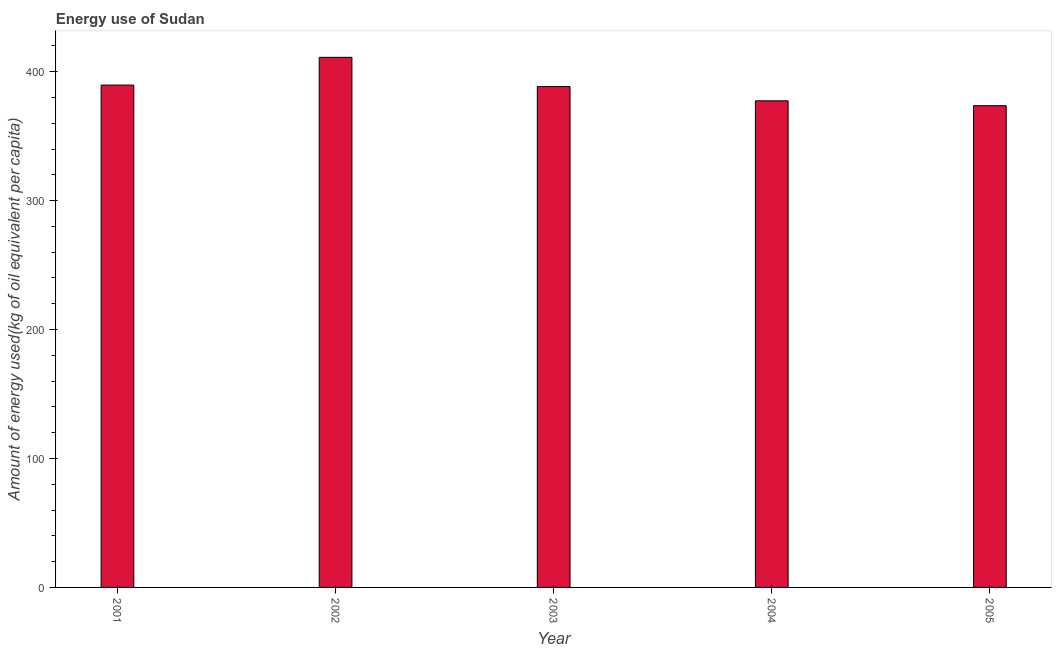Does the graph contain any zero values?
Your answer should be compact. No. What is the title of the graph?
Give a very brief answer. Energy use of Sudan. What is the label or title of the X-axis?
Make the answer very short. Year. What is the label or title of the Y-axis?
Provide a succinct answer. Amount of energy used(kg of oil equivalent per capita). What is the amount of energy used in 2004?
Provide a succinct answer. 377.4. Across all years, what is the maximum amount of energy used?
Ensure brevity in your answer.  411.14. Across all years, what is the minimum amount of energy used?
Offer a very short reply. 373.63. In which year was the amount of energy used maximum?
Offer a terse response. 2002. What is the sum of the amount of energy used?
Your answer should be compact. 1940.25. What is the difference between the amount of energy used in 2001 and 2005?
Give a very brief answer. 15.99. What is the average amount of energy used per year?
Your answer should be compact. 388.05. What is the median amount of energy used?
Your answer should be very brief. 388.46. What is the ratio of the amount of energy used in 2001 to that in 2004?
Give a very brief answer. 1.03. Is the amount of energy used in 2002 less than that in 2005?
Your answer should be very brief. No. Is the difference between the amount of energy used in 2002 and 2005 greater than the difference between any two years?
Give a very brief answer. Yes. What is the difference between the highest and the second highest amount of energy used?
Your response must be concise. 21.51. Is the sum of the amount of energy used in 2003 and 2004 greater than the maximum amount of energy used across all years?
Your response must be concise. Yes. What is the difference between the highest and the lowest amount of energy used?
Your answer should be compact. 37.51. Are all the bars in the graph horizontal?
Offer a terse response. No. What is the Amount of energy used(kg of oil equivalent per capita) in 2001?
Make the answer very short. 389.62. What is the Amount of energy used(kg of oil equivalent per capita) in 2002?
Offer a very short reply. 411.14. What is the Amount of energy used(kg of oil equivalent per capita) in 2003?
Offer a very short reply. 388.46. What is the Amount of energy used(kg of oil equivalent per capita) in 2004?
Your response must be concise. 377.4. What is the Amount of energy used(kg of oil equivalent per capita) in 2005?
Ensure brevity in your answer.  373.63. What is the difference between the Amount of energy used(kg of oil equivalent per capita) in 2001 and 2002?
Offer a very short reply. -21.51. What is the difference between the Amount of energy used(kg of oil equivalent per capita) in 2001 and 2003?
Keep it short and to the point. 1.16. What is the difference between the Amount of energy used(kg of oil equivalent per capita) in 2001 and 2004?
Offer a very short reply. 12.22. What is the difference between the Amount of energy used(kg of oil equivalent per capita) in 2001 and 2005?
Your answer should be very brief. 15.99. What is the difference between the Amount of energy used(kg of oil equivalent per capita) in 2002 and 2003?
Give a very brief answer. 22.68. What is the difference between the Amount of energy used(kg of oil equivalent per capita) in 2002 and 2004?
Ensure brevity in your answer.  33.74. What is the difference between the Amount of energy used(kg of oil equivalent per capita) in 2002 and 2005?
Your answer should be very brief. 37.51. What is the difference between the Amount of energy used(kg of oil equivalent per capita) in 2003 and 2004?
Give a very brief answer. 11.06. What is the difference between the Amount of energy used(kg of oil equivalent per capita) in 2003 and 2005?
Ensure brevity in your answer.  14.83. What is the difference between the Amount of energy used(kg of oil equivalent per capita) in 2004 and 2005?
Provide a succinct answer. 3.77. What is the ratio of the Amount of energy used(kg of oil equivalent per capita) in 2001 to that in 2002?
Your response must be concise. 0.95. What is the ratio of the Amount of energy used(kg of oil equivalent per capita) in 2001 to that in 2004?
Make the answer very short. 1.03. What is the ratio of the Amount of energy used(kg of oil equivalent per capita) in 2001 to that in 2005?
Offer a very short reply. 1.04. What is the ratio of the Amount of energy used(kg of oil equivalent per capita) in 2002 to that in 2003?
Keep it short and to the point. 1.06. What is the ratio of the Amount of energy used(kg of oil equivalent per capita) in 2002 to that in 2004?
Provide a succinct answer. 1.09. What is the ratio of the Amount of energy used(kg of oil equivalent per capita) in 2003 to that in 2004?
Ensure brevity in your answer.  1.03. 